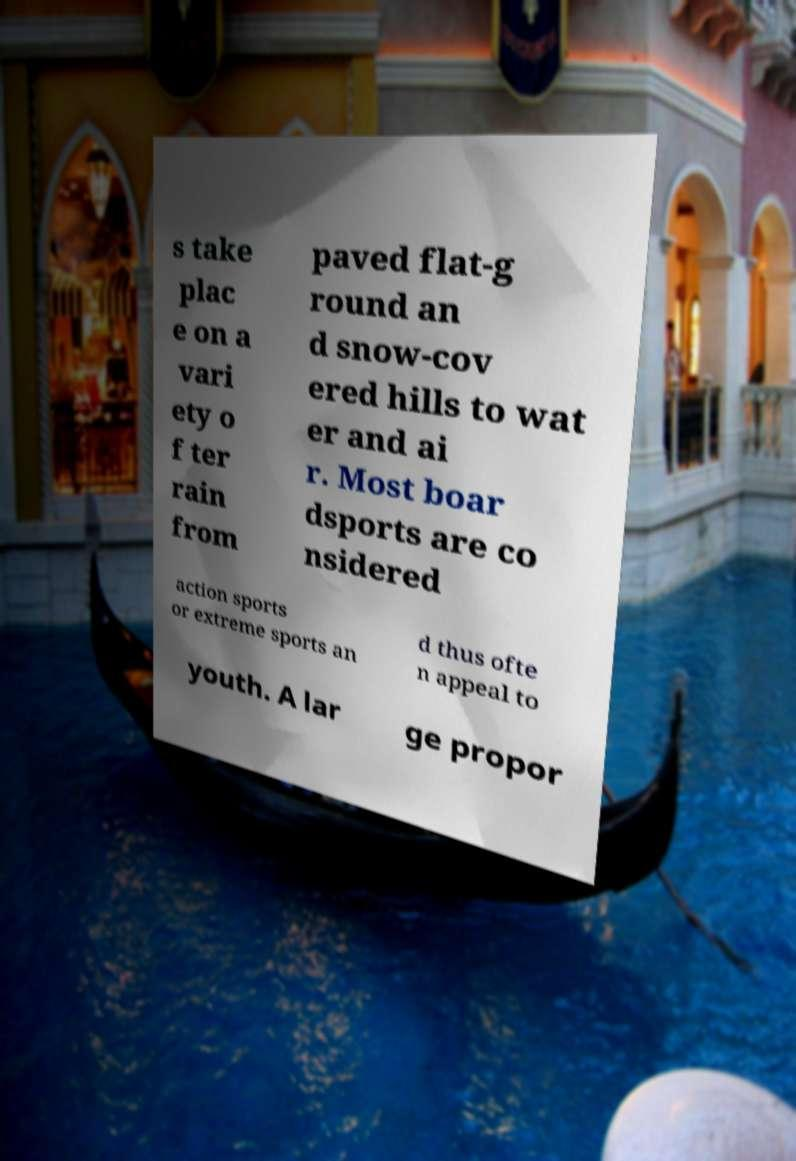For documentation purposes, I need the text within this image transcribed. Could you provide that? s take plac e on a vari ety o f ter rain from paved flat-g round an d snow-cov ered hills to wat er and ai r. Most boar dsports are co nsidered action sports or extreme sports an d thus ofte n appeal to youth. A lar ge propor 